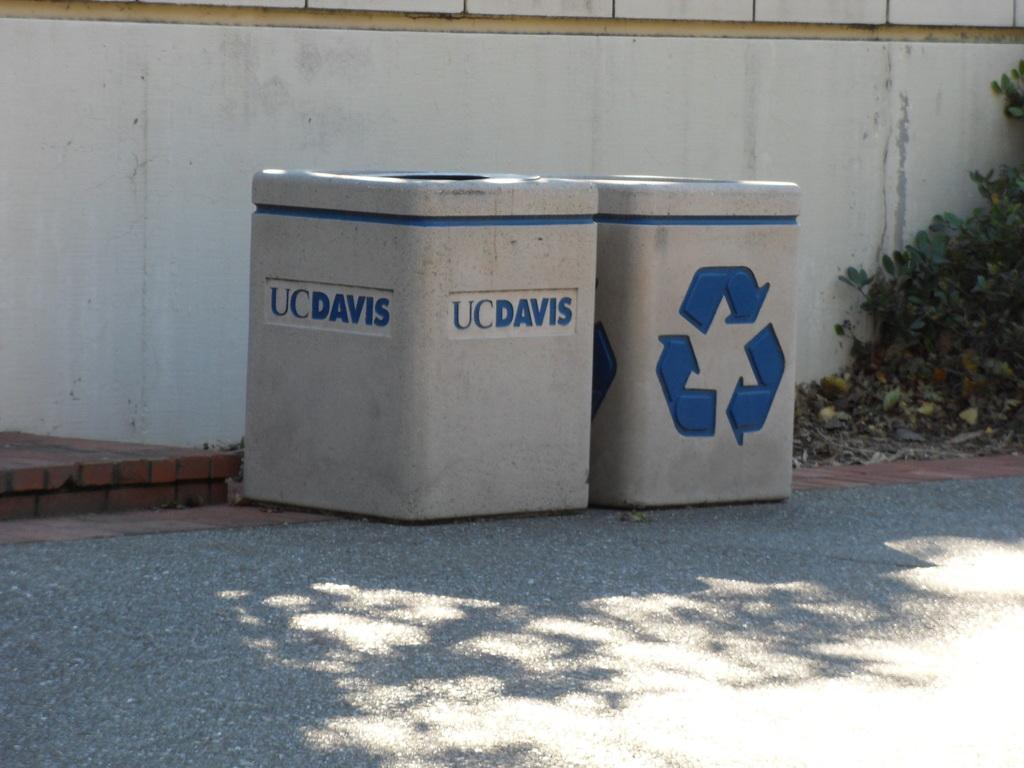Provide a one-sentence caption for the provided image. Two UCDavis recycling bins sit on the concrete. 